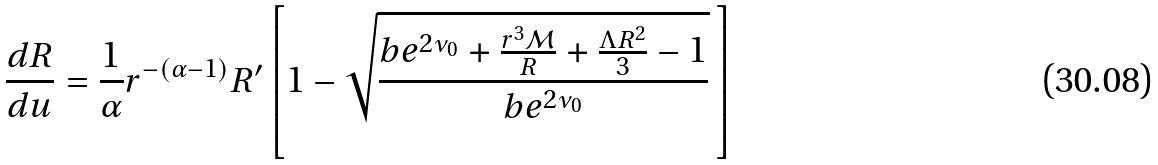Convert formula to latex. <formula><loc_0><loc_0><loc_500><loc_500>\frac { d R } { d u } = \frac { 1 } { \alpha } r ^ { - ( \alpha - 1 ) } R ^ { \prime } \left [ 1 - \sqrt { \frac { b e ^ { 2 \nu _ { 0 } } + \frac { r ^ { 3 } \mathcal { M } } { R } + \frac { \Lambda R ^ { 2 } } { 3 } - 1 } { b e ^ { 2 \nu _ { 0 } } } } \, \right ]</formula> 